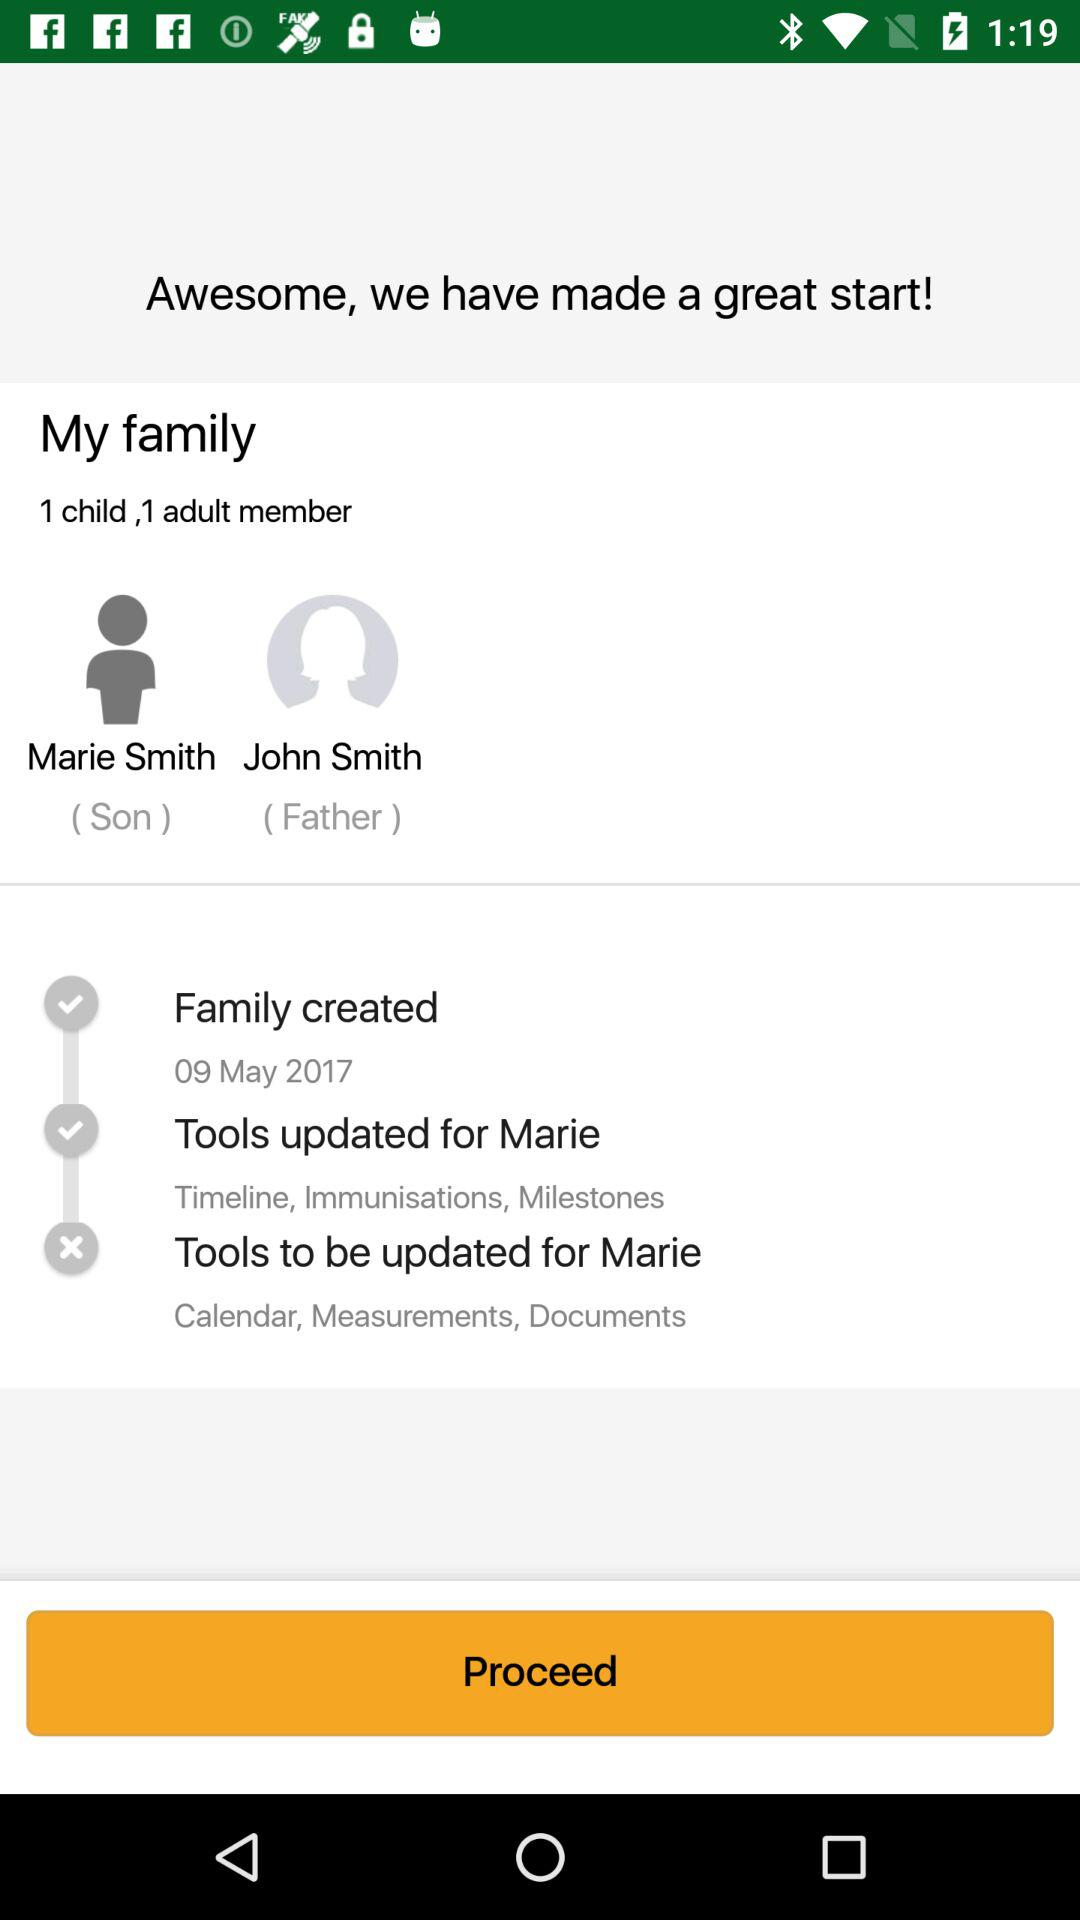What is the date of "Family created"? The date is May 9, 2017. 